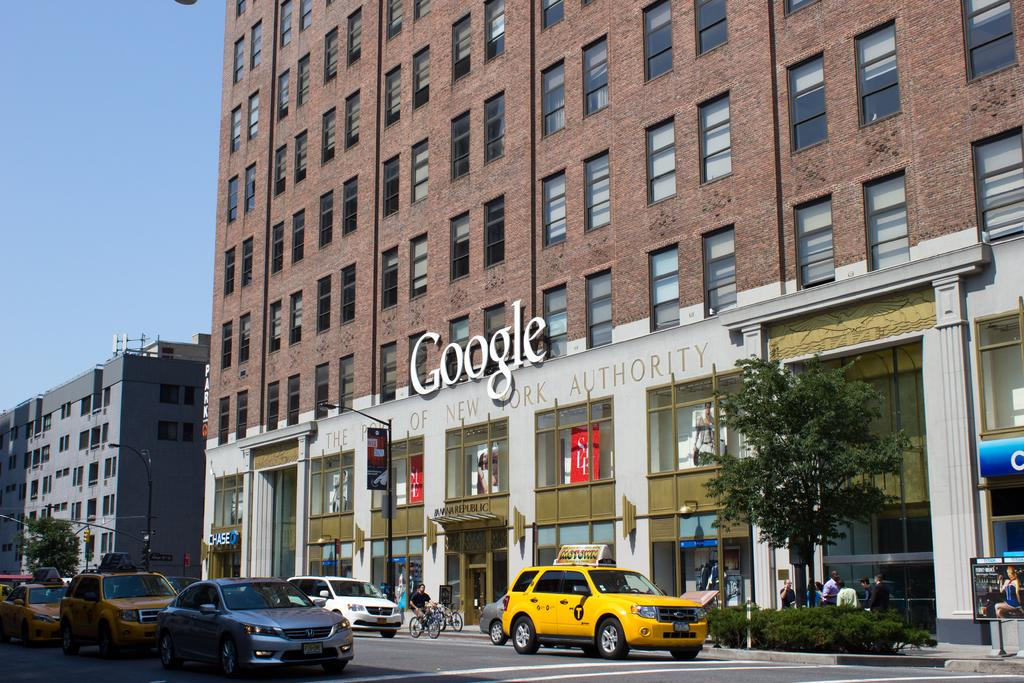<image>
Create a compact narrative representing the image presented. Cars on a busy street in front of a building that says Google 